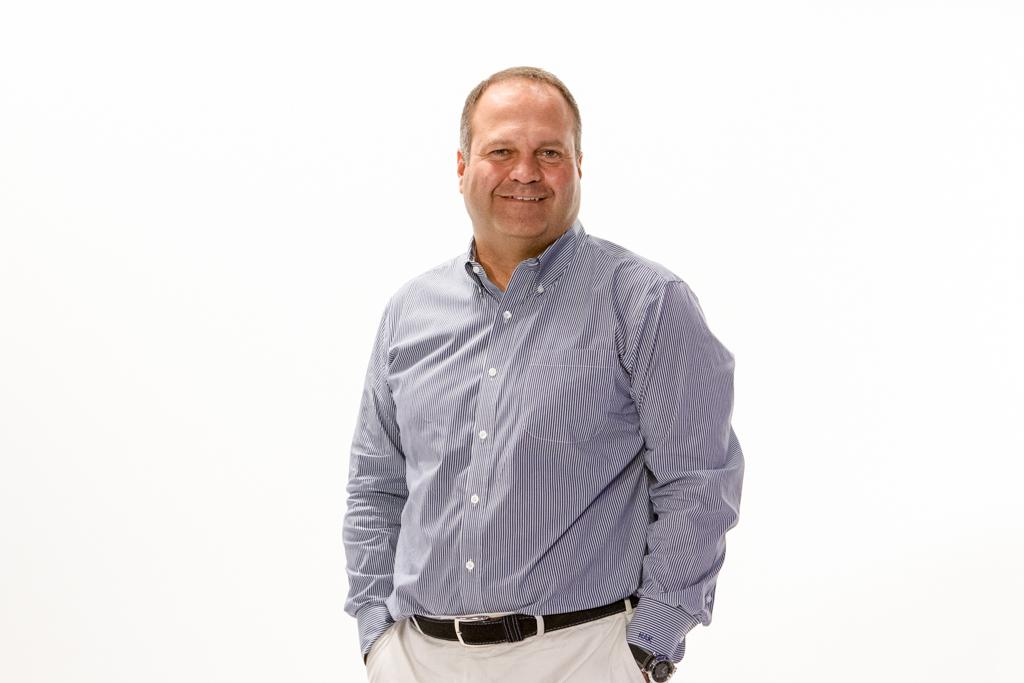What is present in the image? There is a person in the image. How is the person's expression in the image? The person is smiling. What color is the background of the image? The background of the image is white. How much money is the person holding in the image? There is no indication of money or any financial transaction in the image. What type of fowl can be seen in the image? There is no fowl present in the image; it features a person with a white background. 